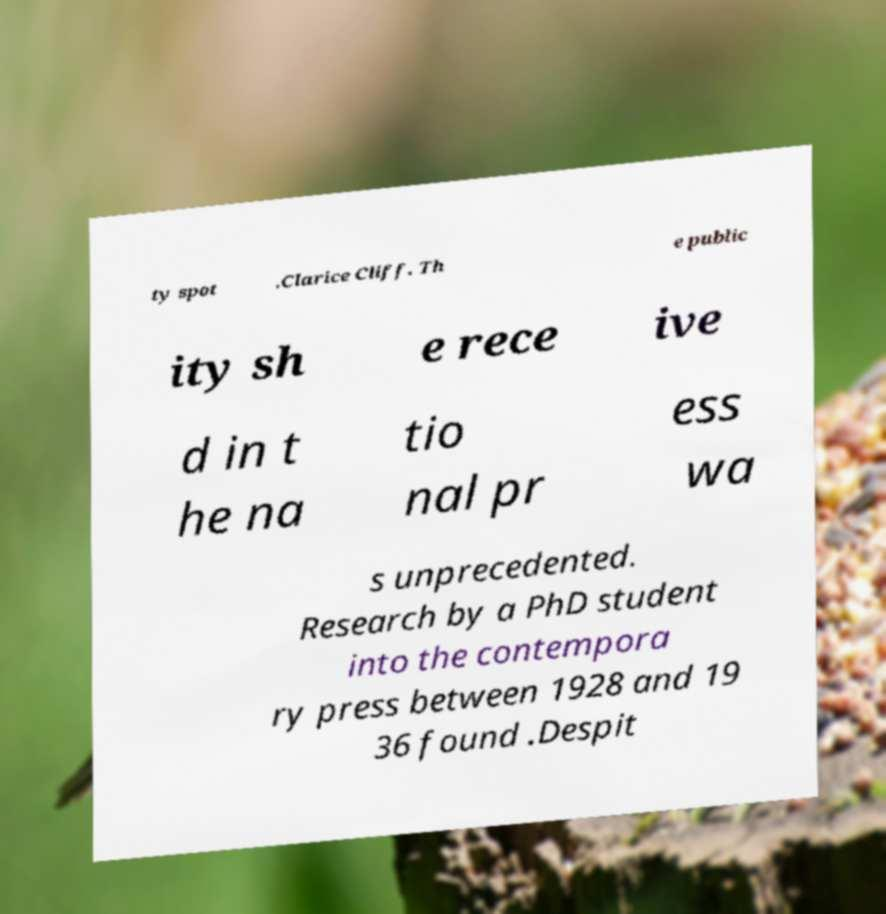I need the written content from this picture converted into text. Can you do that? ty spot .Clarice Cliff. Th e public ity sh e rece ive d in t he na tio nal pr ess wa s unprecedented. Research by a PhD student into the contempora ry press between 1928 and 19 36 found .Despit 